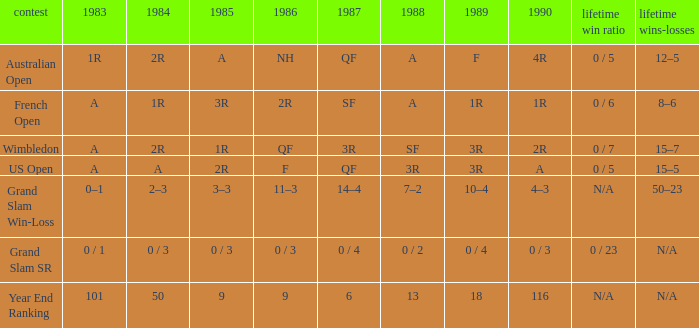With a 1986 of NH and a career SR of 0 / 5 what is the results in 1985? A. 